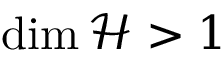<formula> <loc_0><loc_0><loc_500><loc_500>\dim \mathcal { H } > 1</formula> 